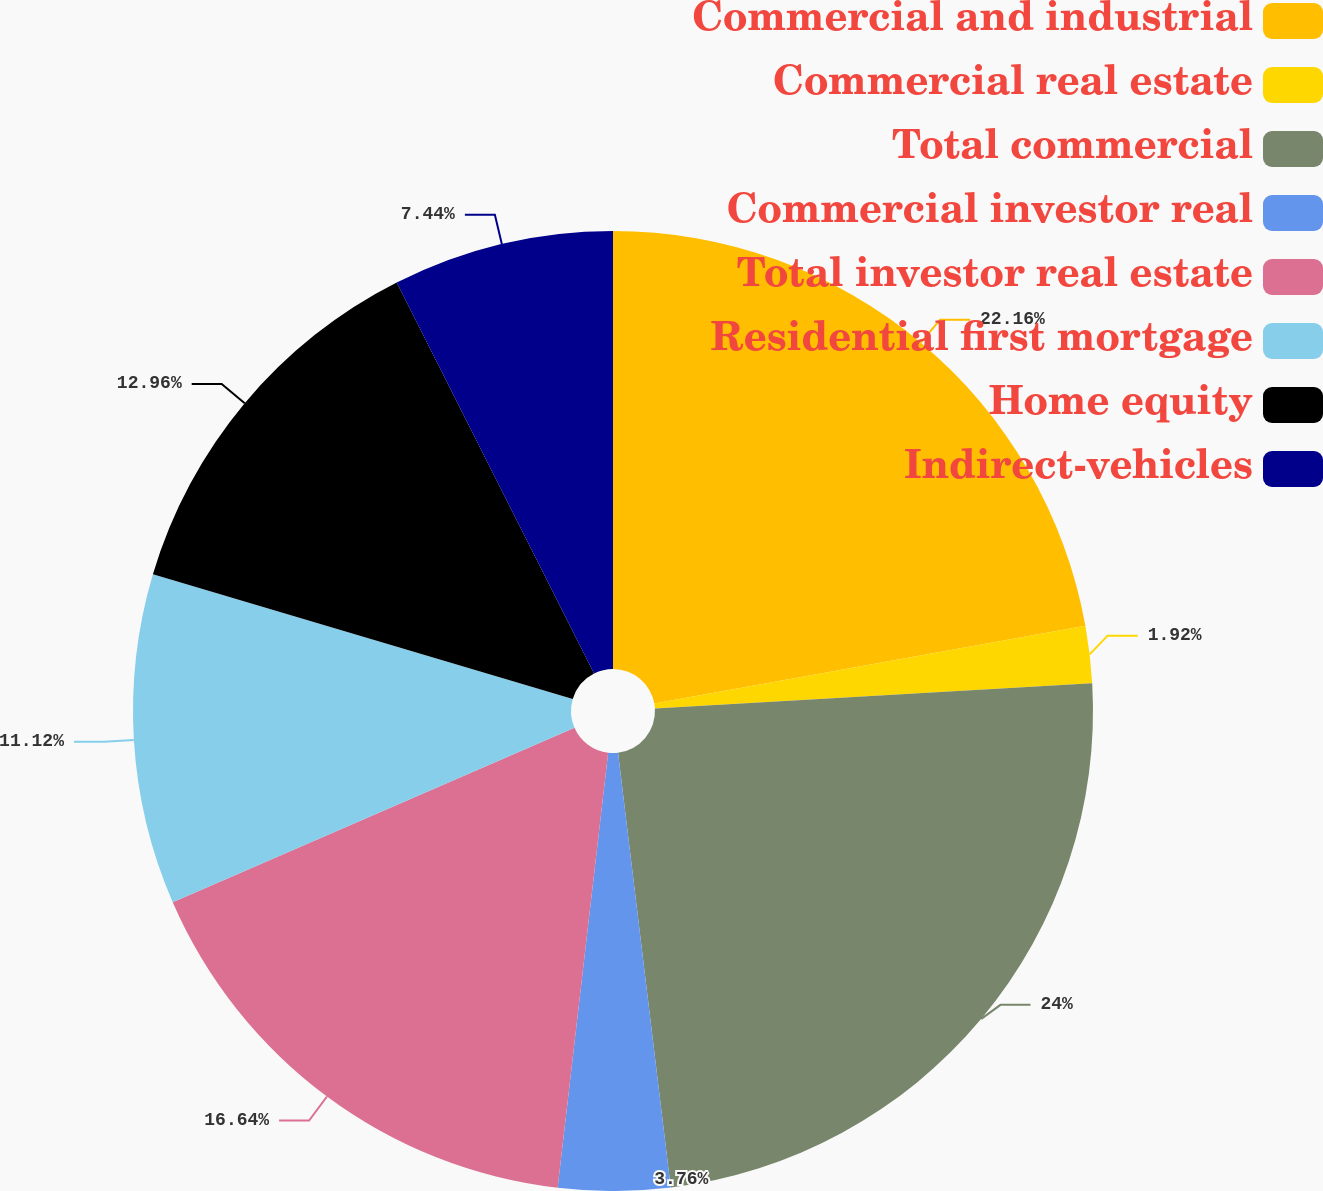Convert chart. <chart><loc_0><loc_0><loc_500><loc_500><pie_chart><fcel>Commercial and industrial<fcel>Commercial real estate<fcel>Total commercial<fcel>Commercial investor real<fcel>Total investor real estate<fcel>Residential first mortgage<fcel>Home equity<fcel>Indirect-vehicles<nl><fcel>22.16%<fcel>1.92%<fcel>24.0%<fcel>3.76%<fcel>16.64%<fcel>11.12%<fcel>12.96%<fcel>7.44%<nl></chart> 